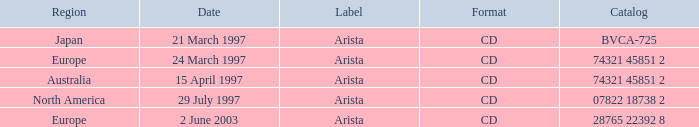What's listed for the Label with a Date of 29 July 1997? Arista. Would you mind parsing the complete table? {'header': ['Region', 'Date', 'Label', 'Format', 'Catalog'], 'rows': [['Japan', '21 March 1997', 'Arista', 'CD', 'BVCA-725'], ['Europe', '24 March 1997', 'Arista', 'CD', '74321 45851 2'], ['Australia', '15 April 1997', 'Arista', 'CD', '74321 45851 2'], ['North America', '29 July 1997', 'Arista', 'CD', '07822 18738 2'], ['Europe', '2 June 2003', 'Arista', 'CD', '28765 22392 8']]} 